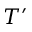<formula> <loc_0><loc_0><loc_500><loc_500>T ^ { \prime }</formula> 